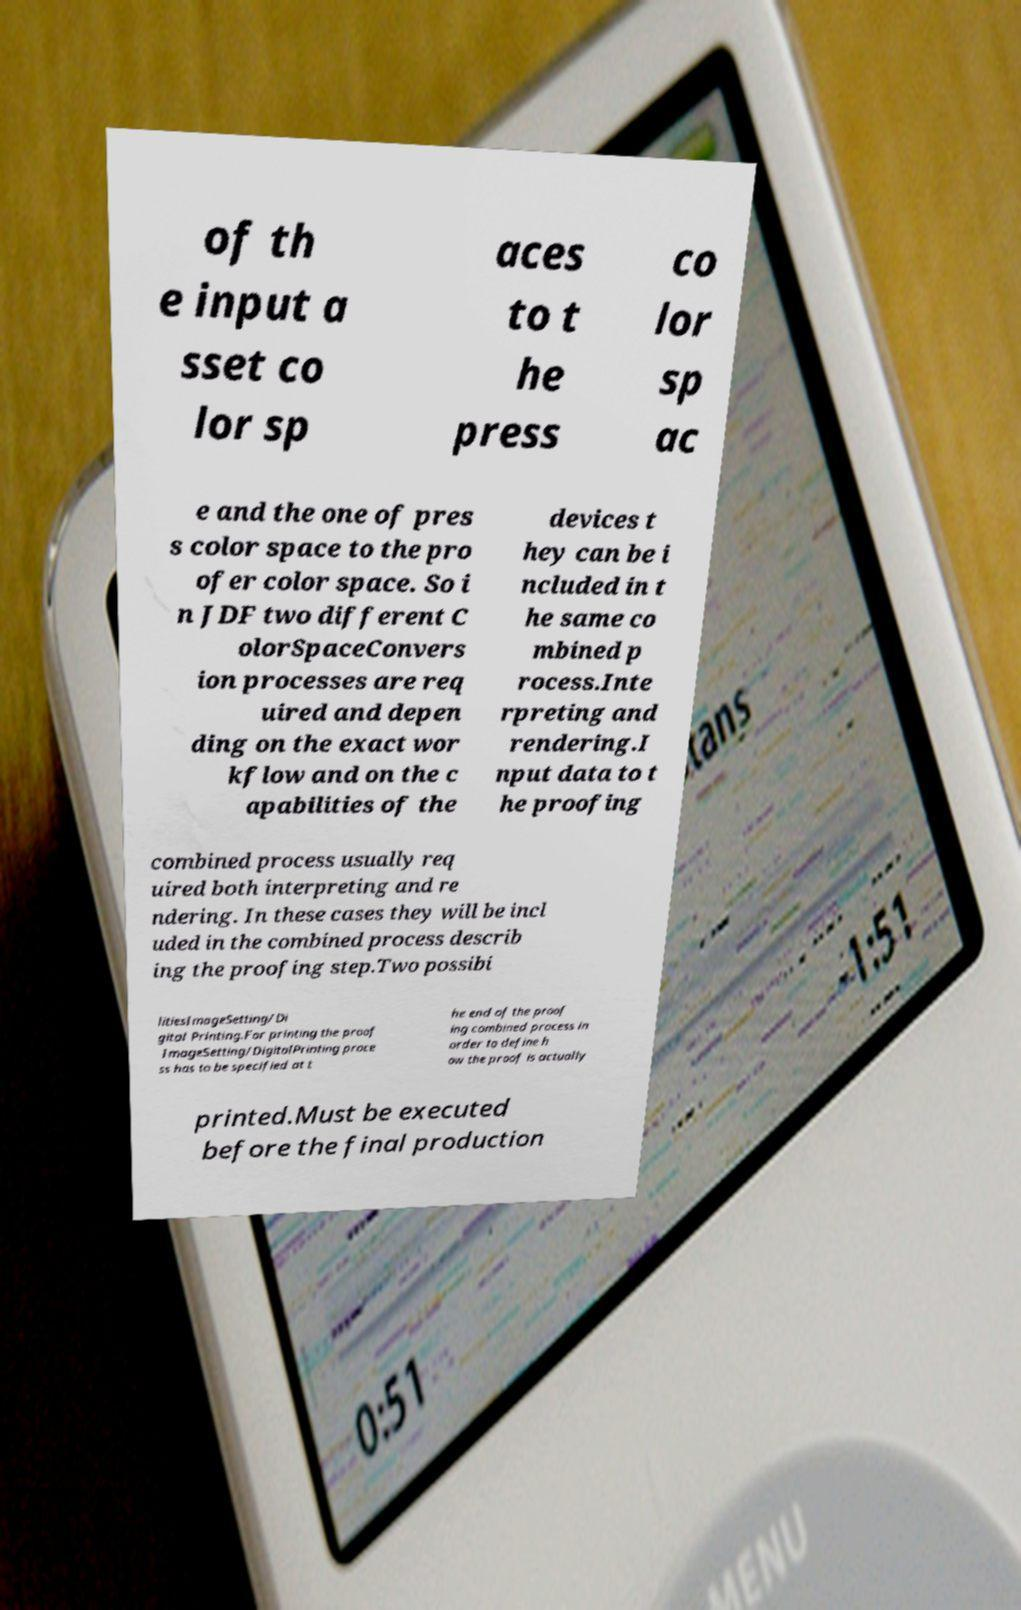Can you read and provide the text displayed in the image?This photo seems to have some interesting text. Can you extract and type it out for me? of th e input a sset co lor sp aces to t he press co lor sp ac e and the one of pres s color space to the pro ofer color space. So i n JDF two different C olorSpaceConvers ion processes are req uired and depen ding on the exact wor kflow and on the c apabilities of the devices t hey can be i ncluded in t he same co mbined p rocess.Inte rpreting and rendering.I nput data to t he proofing combined process usually req uired both interpreting and re ndering. In these cases they will be incl uded in the combined process describ ing the proofing step.Two possibi litiesImageSetting/Di gital Printing.For printing the proof ImageSetting/DigitalPrinting proce ss has to be specified at t he end of the proof ing combined process in order to define h ow the proof is actually printed.Must be executed before the final production 